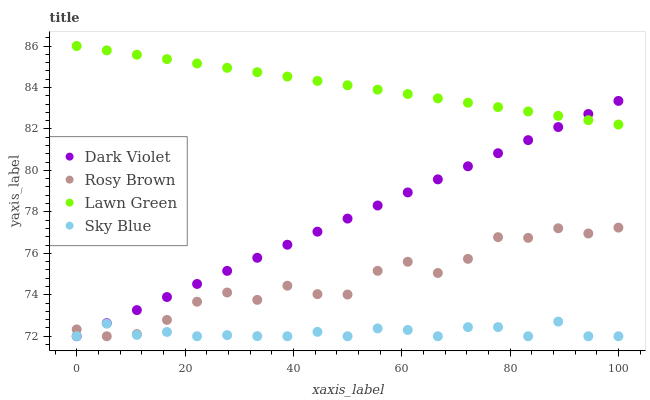Does Sky Blue have the minimum area under the curve?
Answer yes or no. Yes. Does Lawn Green have the maximum area under the curve?
Answer yes or no. Yes. Does Rosy Brown have the minimum area under the curve?
Answer yes or no. No. Does Rosy Brown have the maximum area under the curve?
Answer yes or no. No. Is Lawn Green the smoothest?
Answer yes or no. Yes. Is Rosy Brown the roughest?
Answer yes or no. Yes. Is Dark Violet the smoothest?
Answer yes or no. No. Is Dark Violet the roughest?
Answer yes or no. No. Does Rosy Brown have the lowest value?
Answer yes or no. Yes. Does Lawn Green have the highest value?
Answer yes or no. Yes. Does Rosy Brown have the highest value?
Answer yes or no. No. Is Rosy Brown less than Lawn Green?
Answer yes or no. Yes. Is Lawn Green greater than Sky Blue?
Answer yes or no. Yes. Does Dark Violet intersect Rosy Brown?
Answer yes or no. Yes. Is Dark Violet less than Rosy Brown?
Answer yes or no. No. Is Dark Violet greater than Rosy Brown?
Answer yes or no. No. Does Rosy Brown intersect Lawn Green?
Answer yes or no. No. 